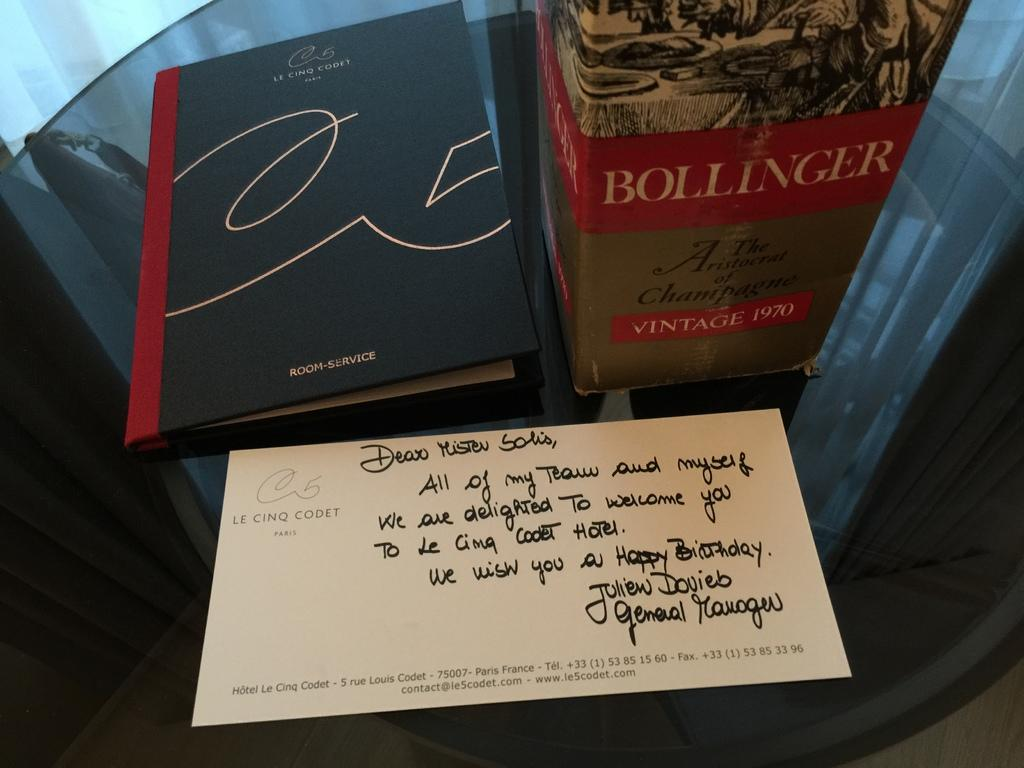<image>
Describe the image concisely. A champagne box with Bollinger on the front. 